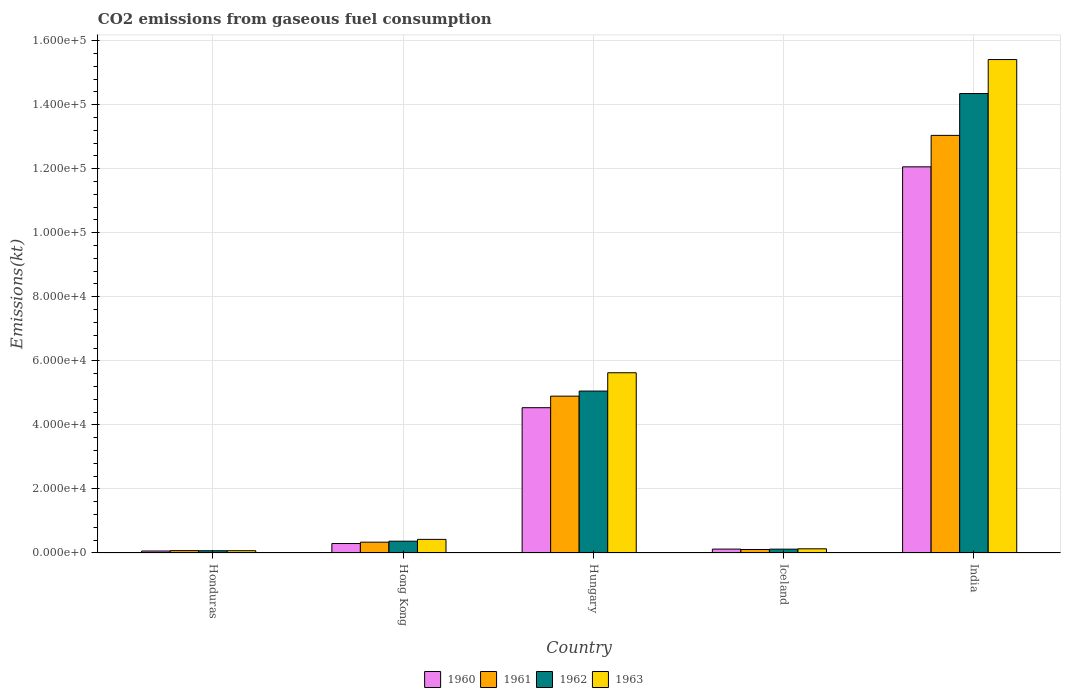Are the number of bars per tick equal to the number of legend labels?
Provide a succinct answer. Yes. How many bars are there on the 5th tick from the left?
Your answer should be very brief. 4. What is the label of the 5th group of bars from the left?
Your answer should be very brief. India. What is the amount of CO2 emitted in 1960 in Iceland?
Ensure brevity in your answer.  1213.78. Across all countries, what is the maximum amount of CO2 emitted in 1960?
Your response must be concise. 1.21e+05. Across all countries, what is the minimum amount of CO2 emitted in 1962?
Give a very brief answer. 700.4. In which country was the amount of CO2 emitted in 1960 maximum?
Provide a succinct answer. India. In which country was the amount of CO2 emitted in 1961 minimum?
Offer a terse response. Honduras. What is the total amount of CO2 emitted in 1963 in the graph?
Ensure brevity in your answer.  2.17e+05. What is the difference between the amount of CO2 emitted in 1962 in Hong Kong and that in India?
Your answer should be very brief. -1.40e+05. What is the difference between the amount of CO2 emitted in 1960 in Iceland and the amount of CO2 emitted in 1963 in Hungary?
Offer a terse response. -5.51e+04. What is the average amount of CO2 emitted in 1960 per country?
Give a very brief answer. 3.41e+04. What is the difference between the amount of CO2 emitted of/in 1963 and amount of CO2 emitted of/in 1960 in Iceland?
Give a very brief answer. 91.67. In how many countries, is the amount of CO2 emitted in 1963 greater than 92000 kt?
Offer a terse response. 1. What is the ratio of the amount of CO2 emitted in 1960 in Hong Kong to that in Hungary?
Offer a very short reply. 0.07. What is the difference between the highest and the second highest amount of CO2 emitted in 1961?
Offer a terse response. -8.14e+04. What is the difference between the highest and the lowest amount of CO2 emitted in 1963?
Make the answer very short. 1.53e+05. In how many countries, is the amount of CO2 emitted in 1962 greater than the average amount of CO2 emitted in 1962 taken over all countries?
Provide a succinct answer. 2. What does the 4th bar from the left in Hong Kong represents?
Your answer should be compact. 1963. What does the 4th bar from the right in Iceland represents?
Provide a short and direct response. 1960. How many bars are there?
Provide a short and direct response. 20. Are the values on the major ticks of Y-axis written in scientific E-notation?
Ensure brevity in your answer.  Yes. Does the graph contain any zero values?
Keep it short and to the point. No. Where does the legend appear in the graph?
Offer a very short reply. Bottom center. How many legend labels are there?
Provide a short and direct response. 4. How are the legend labels stacked?
Ensure brevity in your answer.  Horizontal. What is the title of the graph?
Offer a terse response. CO2 emissions from gaseous fuel consumption. Does "2007" appear as one of the legend labels in the graph?
Offer a very short reply. No. What is the label or title of the Y-axis?
Provide a succinct answer. Emissions(kt). What is the Emissions(kt) of 1960 in Honduras?
Give a very brief answer. 616.06. What is the Emissions(kt) in 1961 in Honduras?
Provide a short and direct response. 737.07. What is the Emissions(kt) in 1962 in Honduras?
Provide a succinct answer. 700.4. What is the Emissions(kt) in 1963 in Honduras?
Your response must be concise. 711.4. What is the Emissions(kt) of 1960 in Hong Kong?
Make the answer very short. 2955.6. What is the Emissions(kt) of 1961 in Hong Kong?
Your answer should be compact. 3373.64. What is the Emissions(kt) in 1962 in Hong Kong?
Your answer should be very brief. 3685.34. What is the Emissions(kt) of 1963 in Hong Kong?
Your answer should be compact. 4250.05. What is the Emissions(kt) of 1960 in Hungary?
Offer a very short reply. 4.54e+04. What is the Emissions(kt) of 1961 in Hungary?
Give a very brief answer. 4.90e+04. What is the Emissions(kt) in 1962 in Hungary?
Offer a terse response. 5.06e+04. What is the Emissions(kt) in 1963 in Hungary?
Offer a terse response. 5.63e+04. What is the Emissions(kt) in 1960 in Iceland?
Make the answer very short. 1213.78. What is the Emissions(kt) in 1961 in Iceland?
Give a very brief answer. 1092.77. What is the Emissions(kt) in 1962 in Iceland?
Make the answer very short. 1199.11. What is the Emissions(kt) in 1963 in Iceland?
Provide a short and direct response. 1305.45. What is the Emissions(kt) in 1960 in India?
Provide a succinct answer. 1.21e+05. What is the Emissions(kt) of 1961 in India?
Make the answer very short. 1.30e+05. What is the Emissions(kt) in 1962 in India?
Offer a terse response. 1.43e+05. What is the Emissions(kt) of 1963 in India?
Your answer should be very brief. 1.54e+05. Across all countries, what is the maximum Emissions(kt) of 1960?
Provide a short and direct response. 1.21e+05. Across all countries, what is the maximum Emissions(kt) of 1961?
Offer a terse response. 1.30e+05. Across all countries, what is the maximum Emissions(kt) of 1962?
Make the answer very short. 1.43e+05. Across all countries, what is the maximum Emissions(kt) of 1963?
Make the answer very short. 1.54e+05. Across all countries, what is the minimum Emissions(kt) of 1960?
Provide a short and direct response. 616.06. Across all countries, what is the minimum Emissions(kt) of 1961?
Ensure brevity in your answer.  737.07. Across all countries, what is the minimum Emissions(kt) of 1962?
Give a very brief answer. 700.4. Across all countries, what is the minimum Emissions(kt) of 1963?
Ensure brevity in your answer.  711.4. What is the total Emissions(kt) in 1960 in the graph?
Offer a terse response. 1.71e+05. What is the total Emissions(kt) in 1961 in the graph?
Ensure brevity in your answer.  1.85e+05. What is the total Emissions(kt) of 1962 in the graph?
Make the answer very short. 2.00e+05. What is the total Emissions(kt) in 1963 in the graph?
Your response must be concise. 2.17e+05. What is the difference between the Emissions(kt) of 1960 in Honduras and that in Hong Kong?
Your answer should be compact. -2339.55. What is the difference between the Emissions(kt) in 1961 in Honduras and that in Hong Kong?
Give a very brief answer. -2636.57. What is the difference between the Emissions(kt) in 1962 in Honduras and that in Hong Kong?
Make the answer very short. -2984.94. What is the difference between the Emissions(kt) of 1963 in Honduras and that in Hong Kong?
Give a very brief answer. -3538.66. What is the difference between the Emissions(kt) in 1960 in Honduras and that in Hungary?
Keep it short and to the point. -4.48e+04. What is the difference between the Emissions(kt) in 1961 in Honduras and that in Hungary?
Your answer should be very brief. -4.82e+04. What is the difference between the Emissions(kt) of 1962 in Honduras and that in Hungary?
Offer a very short reply. -4.99e+04. What is the difference between the Emissions(kt) in 1963 in Honduras and that in Hungary?
Offer a very short reply. -5.56e+04. What is the difference between the Emissions(kt) of 1960 in Honduras and that in Iceland?
Make the answer very short. -597.72. What is the difference between the Emissions(kt) of 1961 in Honduras and that in Iceland?
Keep it short and to the point. -355.7. What is the difference between the Emissions(kt) of 1962 in Honduras and that in Iceland?
Your answer should be compact. -498.71. What is the difference between the Emissions(kt) of 1963 in Honduras and that in Iceland?
Provide a short and direct response. -594.05. What is the difference between the Emissions(kt) in 1960 in Honduras and that in India?
Your answer should be very brief. -1.20e+05. What is the difference between the Emissions(kt) of 1961 in Honduras and that in India?
Keep it short and to the point. -1.30e+05. What is the difference between the Emissions(kt) of 1962 in Honduras and that in India?
Offer a very short reply. -1.43e+05. What is the difference between the Emissions(kt) of 1963 in Honduras and that in India?
Keep it short and to the point. -1.53e+05. What is the difference between the Emissions(kt) in 1960 in Hong Kong and that in Hungary?
Your answer should be very brief. -4.24e+04. What is the difference between the Emissions(kt) of 1961 in Hong Kong and that in Hungary?
Provide a short and direct response. -4.56e+04. What is the difference between the Emissions(kt) in 1962 in Hong Kong and that in Hungary?
Provide a succinct answer. -4.69e+04. What is the difference between the Emissions(kt) in 1963 in Hong Kong and that in Hungary?
Keep it short and to the point. -5.20e+04. What is the difference between the Emissions(kt) in 1960 in Hong Kong and that in Iceland?
Your response must be concise. 1741.83. What is the difference between the Emissions(kt) of 1961 in Hong Kong and that in Iceland?
Give a very brief answer. 2280.87. What is the difference between the Emissions(kt) of 1962 in Hong Kong and that in Iceland?
Provide a short and direct response. 2486.23. What is the difference between the Emissions(kt) of 1963 in Hong Kong and that in Iceland?
Provide a succinct answer. 2944.6. What is the difference between the Emissions(kt) in 1960 in Hong Kong and that in India?
Offer a terse response. -1.18e+05. What is the difference between the Emissions(kt) of 1961 in Hong Kong and that in India?
Ensure brevity in your answer.  -1.27e+05. What is the difference between the Emissions(kt) of 1962 in Hong Kong and that in India?
Give a very brief answer. -1.40e+05. What is the difference between the Emissions(kt) in 1963 in Hong Kong and that in India?
Ensure brevity in your answer.  -1.50e+05. What is the difference between the Emissions(kt) of 1960 in Hungary and that in Iceland?
Offer a terse response. 4.42e+04. What is the difference between the Emissions(kt) of 1961 in Hungary and that in Iceland?
Give a very brief answer. 4.79e+04. What is the difference between the Emissions(kt) of 1962 in Hungary and that in Iceland?
Ensure brevity in your answer.  4.94e+04. What is the difference between the Emissions(kt) of 1963 in Hungary and that in Iceland?
Your answer should be compact. 5.50e+04. What is the difference between the Emissions(kt) of 1960 in Hungary and that in India?
Your answer should be compact. -7.52e+04. What is the difference between the Emissions(kt) in 1961 in Hungary and that in India?
Make the answer very short. -8.14e+04. What is the difference between the Emissions(kt) of 1962 in Hungary and that in India?
Offer a very short reply. -9.29e+04. What is the difference between the Emissions(kt) in 1963 in Hungary and that in India?
Provide a succinct answer. -9.78e+04. What is the difference between the Emissions(kt) in 1960 in Iceland and that in India?
Your answer should be compact. -1.19e+05. What is the difference between the Emissions(kt) in 1961 in Iceland and that in India?
Keep it short and to the point. -1.29e+05. What is the difference between the Emissions(kt) in 1962 in Iceland and that in India?
Keep it short and to the point. -1.42e+05. What is the difference between the Emissions(kt) of 1963 in Iceland and that in India?
Provide a short and direct response. -1.53e+05. What is the difference between the Emissions(kt) in 1960 in Honduras and the Emissions(kt) in 1961 in Hong Kong?
Make the answer very short. -2757.58. What is the difference between the Emissions(kt) of 1960 in Honduras and the Emissions(kt) of 1962 in Hong Kong?
Give a very brief answer. -3069.28. What is the difference between the Emissions(kt) in 1960 in Honduras and the Emissions(kt) in 1963 in Hong Kong?
Your answer should be compact. -3634. What is the difference between the Emissions(kt) of 1961 in Honduras and the Emissions(kt) of 1962 in Hong Kong?
Your answer should be very brief. -2948.27. What is the difference between the Emissions(kt) in 1961 in Honduras and the Emissions(kt) in 1963 in Hong Kong?
Give a very brief answer. -3512.99. What is the difference between the Emissions(kt) of 1962 in Honduras and the Emissions(kt) of 1963 in Hong Kong?
Keep it short and to the point. -3549.66. What is the difference between the Emissions(kt) of 1960 in Honduras and the Emissions(kt) of 1961 in Hungary?
Offer a terse response. -4.84e+04. What is the difference between the Emissions(kt) of 1960 in Honduras and the Emissions(kt) of 1962 in Hungary?
Your answer should be very brief. -4.99e+04. What is the difference between the Emissions(kt) of 1960 in Honduras and the Emissions(kt) of 1963 in Hungary?
Provide a short and direct response. -5.57e+04. What is the difference between the Emissions(kt) of 1961 in Honduras and the Emissions(kt) of 1962 in Hungary?
Give a very brief answer. -4.98e+04. What is the difference between the Emissions(kt) in 1961 in Honduras and the Emissions(kt) in 1963 in Hungary?
Your answer should be compact. -5.55e+04. What is the difference between the Emissions(kt) of 1962 in Honduras and the Emissions(kt) of 1963 in Hungary?
Offer a terse response. -5.56e+04. What is the difference between the Emissions(kt) in 1960 in Honduras and the Emissions(kt) in 1961 in Iceland?
Provide a succinct answer. -476.71. What is the difference between the Emissions(kt) in 1960 in Honduras and the Emissions(kt) in 1962 in Iceland?
Provide a short and direct response. -583.05. What is the difference between the Emissions(kt) in 1960 in Honduras and the Emissions(kt) in 1963 in Iceland?
Your answer should be very brief. -689.4. What is the difference between the Emissions(kt) in 1961 in Honduras and the Emissions(kt) in 1962 in Iceland?
Give a very brief answer. -462.04. What is the difference between the Emissions(kt) in 1961 in Honduras and the Emissions(kt) in 1963 in Iceland?
Your response must be concise. -568.38. What is the difference between the Emissions(kt) of 1962 in Honduras and the Emissions(kt) of 1963 in Iceland?
Provide a short and direct response. -605.05. What is the difference between the Emissions(kt) in 1960 in Honduras and the Emissions(kt) in 1961 in India?
Keep it short and to the point. -1.30e+05. What is the difference between the Emissions(kt) of 1960 in Honduras and the Emissions(kt) of 1962 in India?
Your response must be concise. -1.43e+05. What is the difference between the Emissions(kt) in 1960 in Honduras and the Emissions(kt) in 1963 in India?
Your answer should be very brief. -1.53e+05. What is the difference between the Emissions(kt) of 1961 in Honduras and the Emissions(kt) of 1962 in India?
Provide a succinct answer. -1.43e+05. What is the difference between the Emissions(kt) in 1961 in Honduras and the Emissions(kt) in 1963 in India?
Offer a terse response. -1.53e+05. What is the difference between the Emissions(kt) in 1962 in Honduras and the Emissions(kt) in 1963 in India?
Your response must be concise. -1.53e+05. What is the difference between the Emissions(kt) in 1960 in Hong Kong and the Emissions(kt) in 1961 in Hungary?
Your answer should be compact. -4.60e+04. What is the difference between the Emissions(kt) in 1960 in Hong Kong and the Emissions(kt) in 1962 in Hungary?
Keep it short and to the point. -4.76e+04. What is the difference between the Emissions(kt) of 1960 in Hong Kong and the Emissions(kt) of 1963 in Hungary?
Your response must be concise. -5.33e+04. What is the difference between the Emissions(kt) of 1961 in Hong Kong and the Emissions(kt) of 1962 in Hungary?
Ensure brevity in your answer.  -4.72e+04. What is the difference between the Emissions(kt) of 1961 in Hong Kong and the Emissions(kt) of 1963 in Hungary?
Your answer should be compact. -5.29e+04. What is the difference between the Emissions(kt) in 1962 in Hong Kong and the Emissions(kt) in 1963 in Hungary?
Keep it short and to the point. -5.26e+04. What is the difference between the Emissions(kt) of 1960 in Hong Kong and the Emissions(kt) of 1961 in Iceland?
Keep it short and to the point. 1862.84. What is the difference between the Emissions(kt) in 1960 in Hong Kong and the Emissions(kt) in 1962 in Iceland?
Your response must be concise. 1756.49. What is the difference between the Emissions(kt) of 1960 in Hong Kong and the Emissions(kt) of 1963 in Iceland?
Your answer should be very brief. 1650.15. What is the difference between the Emissions(kt) of 1961 in Hong Kong and the Emissions(kt) of 1962 in Iceland?
Provide a short and direct response. 2174.53. What is the difference between the Emissions(kt) of 1961 in Hong Kong and the Emissions(kt) of 1963 in Iceland?
Your answer should be very brief. 2068.19. What is the difference between the Emissions(kt) of 1962 in Hong Kong and the Emissions(kt) of 1963 in Iceland?
Your response must be concise. 2379.88. What is the difference between the Emissions(kt) in 1960 in Hong Kong and the Emissions(kt) in 1961 in India?
Provide a short and direct response. -1.27e+05. What is the difference between the Emissions(kt) in 1960 in Hong Kong and the Emissions(kt) in 1962 in India?
Your response must be concise. -1.41e+05. What is the difference between the Emissions(kt) in 1960 in Hong Kong and the Emissions(kt) in 1963 in India?
Offer a terse response. -1.51e+05. What is the difference between the Emissions(kt) in 1961 in Hong Kong and the Emissions(kt) in 1962 in India?
Provide a short and direct response. -1.40e+05. What is the difference between the Emissions(kt) in 1961 in Hong Kong and the Emissions(kt) in 1963 in India?
Give a very brief answer. -1.51e+05. What is the difference between the Emissions(kt) of 1962 in Hong Kong and the Emissions(kt) of 1963 in India?
Make the answer very short. -1.50e+05. What is the difference between the Emissions(kt) of 1960 in Hungary and the Emissions(kt) of 1961 in Iceland?
Make the answer very short. 4.43e+04. What is the difference between the Emissions(kt) of 1960 in Hungary and the Emissions(kt) of 1962 in Iceland?
Keep it short and to the point. 4.42e+04. What is the difference between the Emissions(kt) of 1960 in Hungary and the Emissions(kt) of 1963 in Iceland?
Your answer should be compact. 4.41e+04. What is the difference between the Emissions(kt) in 1961 in Hungary and the Emissions(kt) in 1962 in Iceland?
Make the answer very short. 4.78e+04. What is the difference between the Emissions(kt) in 1961 in Hungary and the Emissions(kt) in 1963 in Iceland?
Offer a very short reply. 4.77e+04. What is the difference between the Emissions(kt) in 1962 in Hungary and the Emissions(kt) in 1963 in Iceland?
Your answer should be compact. 4.93e+04. What is the difference between the Emissions(kt) of 1960 in Hungary and the Emissions(kt) of 1961 in India?
Your response must be concise. -8.50e+04. What is the difference between the Emissions(kt) in 1960 in Hungary and the Emissions(kt) in 1962 in India?
Your response must be concise. -9.81e+04. What is the difference between the Emissions(kt) in 1960 in Hungary and the Emissions(kt) in 1963 in India?
Provide a short and direct response. -1.09e+05. What is the difference between the Emissions(kt) of 1961 in Hungary and the Emissions(kt) of 1962 in India?
Offer a terse response. -9.45e+04. What is the difference between the Emissions(kt) of 1961 in Hungary and the Emissions(kt) of 1963 in India?
Provide a short and direct response. -1.05e+05. What is the difference between the Emissions(kt) of 1962 in Hungary and the Emissions(kt) of 1963 in India?
Offer a very short reply. -1.04e+05. What is the difference between the Emissions(kt) in 1960 in Iceland and the Emissions(kt) in 1961 in India?
Your answer should be very brief. -1.29e+05. What is the difference between the Emissions(kt) of 1960 in Iceland and the Emissions(kt) of 1962 in India?
Your response must be concise. -1.42e+05. What is the difference between the Emissions(kt) of 1960 in Iceland and the Emissions(kt) of 1963 in India?
Your answer should be very brief. -1.53e+05. What is the difference between the Emissions(kt) in 1961 in Iceland and the Emissions(kt) in 1962 in India?
Offer a very short reply. -1.42e+05. What is the difference between the Emissions(kt) of 1961 in Iceland and the Emissions(kt) of 1963 in India?
Offer a terse response. -1.53e+05. What is the difference between the Emissions(kt) of 1962 in Iceland and the Emissions(kt) of 1963 in India?
Keep it short and to the point. -1.53e+05. What is the average Emissions(kt) in 1960 per country?
Ensure brevity in your answer.  3.41e+04. What is the average Emissions(kt) in 1961 per country?
Offer a terse response. 3.69e+04. What is the average Emissions(kt) in 1962 per country?
Offer a terse response. 3.99e+04. What is the average Emissions(kt) in 1963 per country?
Your answer should be very brief. 4.33e+04. What is the difference between the Emissions(kt) in 1960 and Emissions(kt) in 1961 in Honduras?
Provide a short and direct response. -121.01. What is the difference between the Emissions(kt) of 1960 and Emissions(kt) of 1962 in Honduras?
Offer a terse response. -84.34. What is the difference between the Emissions(kt) of 1960 and Emissions(kt) of 1963 in Honduras?
Keep it short and to the point. -95.34. What is the difference between the Emissions(kt) of 1961 and Emissions(kt) of 1962 in Honduras?
Give a very brief answer. 36.67. What is the difference between the Emissions(kt) of 1961 and Emissions(kt) of 1963 in Honduras?
Your answer should be very brief. 25.67. What is the difference between the Emissions(kt) of 1962 and Emissions(kt) of 1963 in Honduras?
Offer a very short reply. -11. What is the difference between the Emissions(kt) of 1960 and Emissions(kt) of 1961 in Hong Kong?
Provide a succinct answer. -418.04. What is the difference between the Emissions(kt) in 1960 and Emissions(kt) in 1962 in Hong Kong?
Give a very brief answer. -729.73. What is the difference between the Emissions(kt) in 1960 and Emissions(kt) in 1963 in Hong Kong?
Your answer should be compact. -1294.45. What is the difference between the Emissions(kt) of 1961 and Emissions(kt) of 1962 in Hong Kong?
Your answer should be compact. -311.69. What is the difference between the Emissions(kt) of 1961 and Emissions(kt) of 1963 in Hong Kong?
Offer a terse response. -876.41. What is the difference between the Emissions(kt) of 1962 and Emissions(kt) of 1963 in Hong Kong?
Make the answer very short. -564.72. What is the difference between the Emissions(kt) in 1960 and Emissions(kt) in 1961 in Hungary?
Your answer should be compact. -3604.66. What is the difference between the Emissions(kt) in 1960 and Emissions(kt) in 1962 in Hungary?
Your answer should be very brief. -5188.81. What is the difference between the Emissions(kt) in 1960 and Emissions(kt) in 1963 in Hungary?
Make the answer very short. -1.09e+04. What is the difference between the Emissions(kt) of 1961 and Emissions(kt) of 1962 in Hungary?
Ensure brevity in your answer.  -1584.14. What is the difference between the Emissions(kt) in 1961 and Emissions(kt) in 1963 in Hungary?
Provide a short and direct response. -7304.66. What is the difference between the Emissions(kt) of 1962 and Emissions(kt) of 1963 in Hungary?
Provide a short and direct response. -5720.52. What is the difference between the Emissions(kt) of 1960 and Emissions(kt) of 1961 in Iceland?
Offer a terse response. 121.01. What is the difference between the Emissions(kt) of 1960 and Emissions(kt) of 1962 in Iceland?
Your answer should be compact. 14.67. What is the difference between the Emissions(kt) in 1960 and Emissions(kt) in 1963 in Iceland?
Your answer should be compact. -91.67. What is the difference between the Emissions(kt) of 1961 and Emissions(kt) of 1962 in Iceland?
Provide a succinct answer. -106.34. What is the difference between the Emissions(kt) of 1961 and Emissions(kt) of 1963 in Iceland?
Your answer should be very brief. -212.69. What is the difference between the Emissions(kt) in 1962 and Emissions(kt) in 1963 in Iceland?
Keep it short and to the point. -106.34. What is the difference between the Emissions(kt) in 1960 and Emissions(kt) in 1961 in India?
Make the answer very short. -9820.23. What is the difference between the Emissions(kt) in 1960 and Emissions(kt) in 1962 in India?
Offer a very short reply. -2.29e+04. What is the difference between the Emissions(kt) in 1960 and Emissions(kt) in 1963 in India?
Make the answer very short. -3.35e+04. What is the difference between the Emissions(kt) of 1961 and Emissions(kt) of 1962 in India?
Keep it short and to the point. -1.31e+04. What is the difference between the Emissions(kt) in 1961 and Emissions(kt) in 1963 in India?
Ensure brevity in your answer.  -2.37e+04. What is the difference between the Emissions(kt) of 1962 and Emissions(kt) of 1963 in India?
Offer a very short reply. -1.06e+04. What is the ratio of the Emissions(kt) of 1960 in Honduras to that in Hong Kong?
Your answer should be compact. 0.21. What is the ratio of the Emissions(kt) in 1961 in Honduras to that in Hong Kong?
Make the answer very short. 0.22. What is the ratio of the Emissions(kt) in 1962 in Honduras to that in Hong Kong?
Ensure brevity in your answer.  0.19. What is the ratio of the Emissions(kt) of 1963 in Honduras to that in Hong Kong?
Offer a very short reply. 0.17. What is the ratio of the Emissions(kt) in 1960 in Honduras to that in Hungary?
Provide a short and direct response. 0.01. What is the ratio of the Emissions(kt) of 1961 in Honduras to that in Hungary?
Ensure brevity in your answer.  0.01. What is the ratio of the Emissions(kt) in 1962 in Honduras to that in Hungary?
Offer a very short reply. 0.01. What is the ratio of the Emissions(kt) in 1963 in Honduras to that in Hungary?
Your answer should be very brief. 0.01. What is the ratio of the Emissions(kt) of 1960 in Honduras to that in Iceland?
Make the answer very short. 0.51. What is the ratio of the Emissions(kt) in 1961 in Honduras to that in Iceland?
Give a very brief answer. 0.67. What is the ratio of the Emissions(kt) of 1962 in Honduras to that in Iceland?
Offer a very short reply. 0.58. What is the ratio of the Emissions(kt) of 1963 in Honduras to that in Iceland?
Ensure brevity in your answer.  0.54. What is the ratio of the Emissions(kt) of 1960 in Honduras to that in India?
Your answer should be compact. 0.01. What is the ratio of the Emissions(kt) in 1961 in Honduras to that in India?
Ensure brevity in your answer.  0.01. What is the ratio of the Emissions(kt) in 1962 in Honduras to that in India?
Your answer should be compact. 0. What is the ratio of the Emissions(kt) in 1963 in Honduras to that in India?
Offer a very short reply. 0. What is the ratio of the Emissions(kt) of 1960 in Hong Kong to that in Hungary?
Offer a terse response. 0.07. What is the ratio of the Emissions(kt) of 1961 in Hong Kong to that in Hungary?
Provide a short and direct response. 0.07. What is the ratio of the Emissions(kt) in 1962 in Hong Kong to that in Hungary?
Your answer should be very brief. 0.07. What is the ratio of the Emissions(kt) in 1963 in Hong Kong to that in Hungary?
Keep it short and to the point. 0.08. What is the ratio of the Emissions(kt) of 1960 in Hong Kong to that in Iceland?
Offer a very short reply. 2.44. What is the ratio of the Emissions(kt) in 1961 in Hong Kong to that in Iceland?
Provide a succinct answer. 3.09. What is the ratio of the Emissions(kt) of 1962 in Hong Kong to that in Iceland?
Your answer should be compact. 3.07. What is the ratio of the Emissions(kt) of 1963 in Hong Kong to that in Iceland?
Provide a short and direct response. 3.26. What is the ratio of the Emissions(kt) of 1960 in Hong Kong to that in India?
Offer a very short reply. 0.02. What is the ratio of the Emissions(kt) of 1961 in Hong Kong to that in India?
Your answer should be compact. 0.03. What is the ratio of the Emissions(kt) in 1962 in Hong Kong to that in India?
Ensure brevity in your answer.  0.03. What is the ratio of the Emissions(kt) in 1963 in Hong Kong to that in India?
Ensure brevity in your answer.  0.03. What is the ratio of the Emissions(kt) in 1960 in Hungary to that in Iceland?
Your answer should be compact. 37.38. What is the ratio of the Emissions(kt) in 1961 in Hungary to that in Iceland?
Your response must be concise. 44.82. What is the ratio of the Emissions(kt) in 1962 in Hungary to that in Iceland?
Your answer should be very brief. 42.17. What is the ratio of the Emissions(kt) in 1963 in Hungary to that in Iceland?
Offer a very short reply. 43.11. What is the ratio of the Emissions(kt) of 1960 in Hungary to that in India?
Make the answer very short. 0.38. What is the ratio of the Emissions(kt) in 1961 in Hungary to that in India?
Offer a very short reply. 0.38. What is the ratio of the Emissions(kt) of 1962 in Hungary to that in India?
Offer a very short reply. 0.35. What is the ratio of the Emissions(kt) of 1963 in Hungary to that in India?
Your answer should be compact. 0.37. What is the ratio of the Emissions(kt) of 1960 in Iceland to that in India?
Provide a succinct answer. 0.01. What is the ratio of the Emissions(kt) in 1961 in Iceland to that in India?
Offer a terse response. 0.01. What is the ratio of the Emissions(kt) in 1962 in Iceland to that in India?
Make the answer very short. 0.01. What is the ratio of the Emissions(kt) in 1963 in Iceland to that in India?
Your response must be concise. 0.01. What is the difference between the highest and the second highest Emissions(kt) of 1960?
Your response must be concise. 7.52e+04. What is the difference between the highest and the second highest Emissions(kt) in 1961?
Make the answer very short. 8.14e+04. What is the difference between the highest and the second highest Emissions(kt) in 1962?
Make the answer very short. 9.29e+04. What is the difference between the highest and the second highest Emissions(kt) of 1963?
Provide a short and direct response. 9.78e+04. What is the difference between the highest and the lowest Emissions(kt) of 1960?
Offer a terse response. 1.20e+05. What is the difference between the highest and the lowest Emissions(kt) in 1961?
Your answer should be very brief. 1.30e+05. What is the difference between the highest and the lowest Emissions(kt) of 1962?
Your response must be concise. 1.43e+05. What is the difference between the highest and the lowest Emissions(kt) of 1963?
Your answer should be compact. 1.53e+05. 